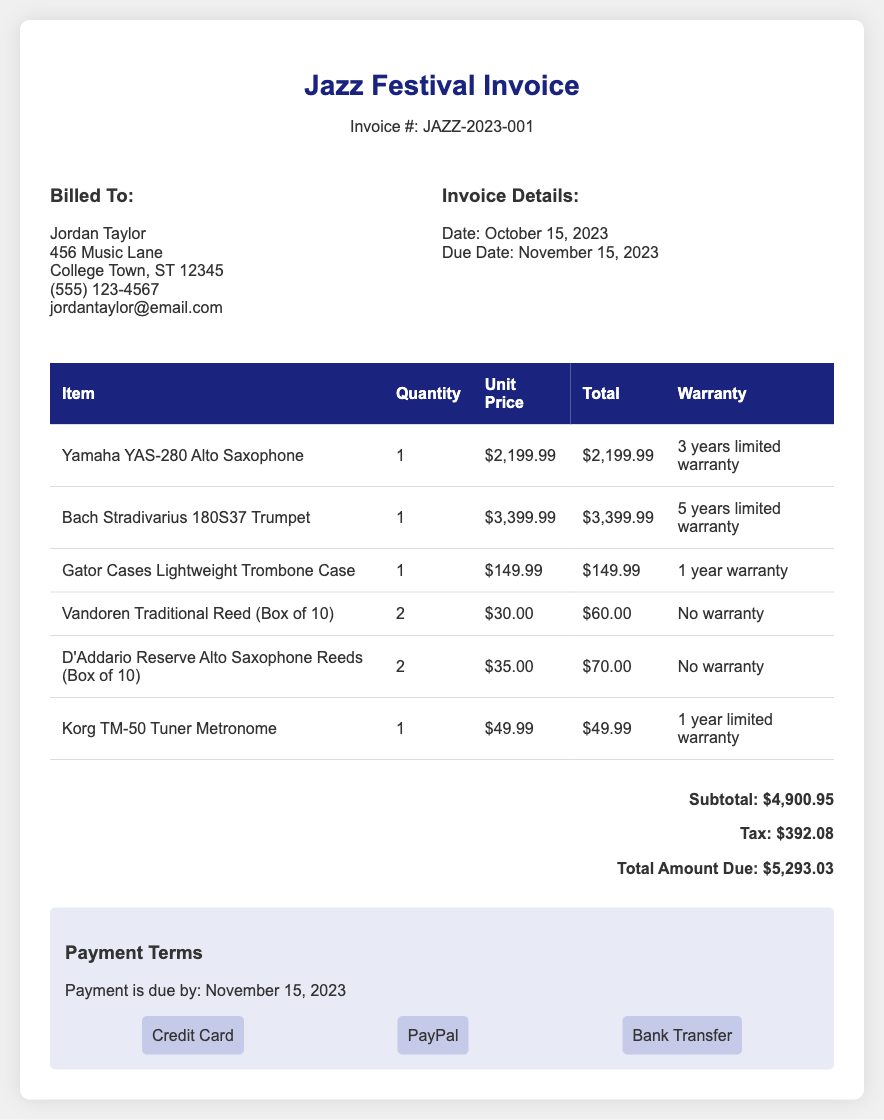What is the invoice number? The invoice number is displayed prominently in the header section of the document, which is JAZZ-2023-001.
Answer: JAZZ-2023-001 Who is billed in the invoice? The billing information contains the name of the individual or entity being billed, which is Jordan Taylor.
Answer: Jordan Taylor What is the total amount due? The total amount due is listed at the end of the document, which includes the subtotal and tax, amounting to $5,293.03.
Answer: $5,293.03 What is the warranty period for the Yamaha YAS-280 Alto Saxophone? The warranty information for the corresponding instrument is noted in the table, specifying a 3 years limited warranty.
Answer: 3 years limited warranty How many items were purchased? The total number of distinct items in the invoice can be calculated from the table, which lists six different items purchased.
Answer: 6 items What payment methods are accepted? The payment methods are explicitly listed in a section of the document, including Credit Card, PayPal, and Bank Transfer.
Answer: Credit Card, PayPal, Bank Transfer What is the due date for payment? The due date for payment is mentioned in the invoice details, which is November 15, 2023.
Answer: November 15, 2023 What is the unit price of the Bach Stradivarius 180S37 Trumpet? The unit price is presented in the table for each item, which shows the price for the trumpet as $3,399.99.
Answer: $3,399.99 What is the subtotal before tax? The subtotal is provided in the total section of the document, indicating the sum before tax calculations, which is $4,900.95.
Answer: $4,900.95 